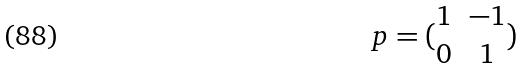Convert formula to latex. <formula><loc_0><loc_0><loc_500><loc_500>p = ( \begin{matrix} 1 & - 1 \\ 0 & 1 \end{matrix} )</formula> 